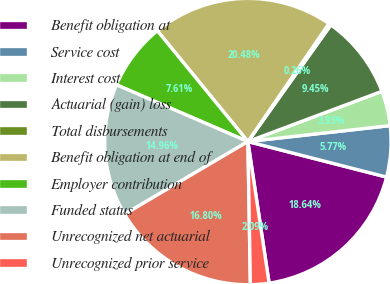Convert chart. <chart><loc_0><loc_0><loc_500><loc_500><pie_chart><fcel>Benefit obligation at<fcel>Service cost<fcel>Interest cost<fcel>Actuarial (gain) loss<fcel>Total disbursements<fcel>Benefit obligation at end of<fcel>Employer contribution<fcel>Funded status<fcel>Unrecognized net actuarial<fcel>Unrecognized prior service<nl><fcel>18.64%<fcel>5.77%<fcel>3.93%<fcel>9.45%<fcel>0.26%<fcel>20.48%<fcel>7.61%<fcel>14.96%<fcel>16.8%<fcel>2.09%<nl></chart> 